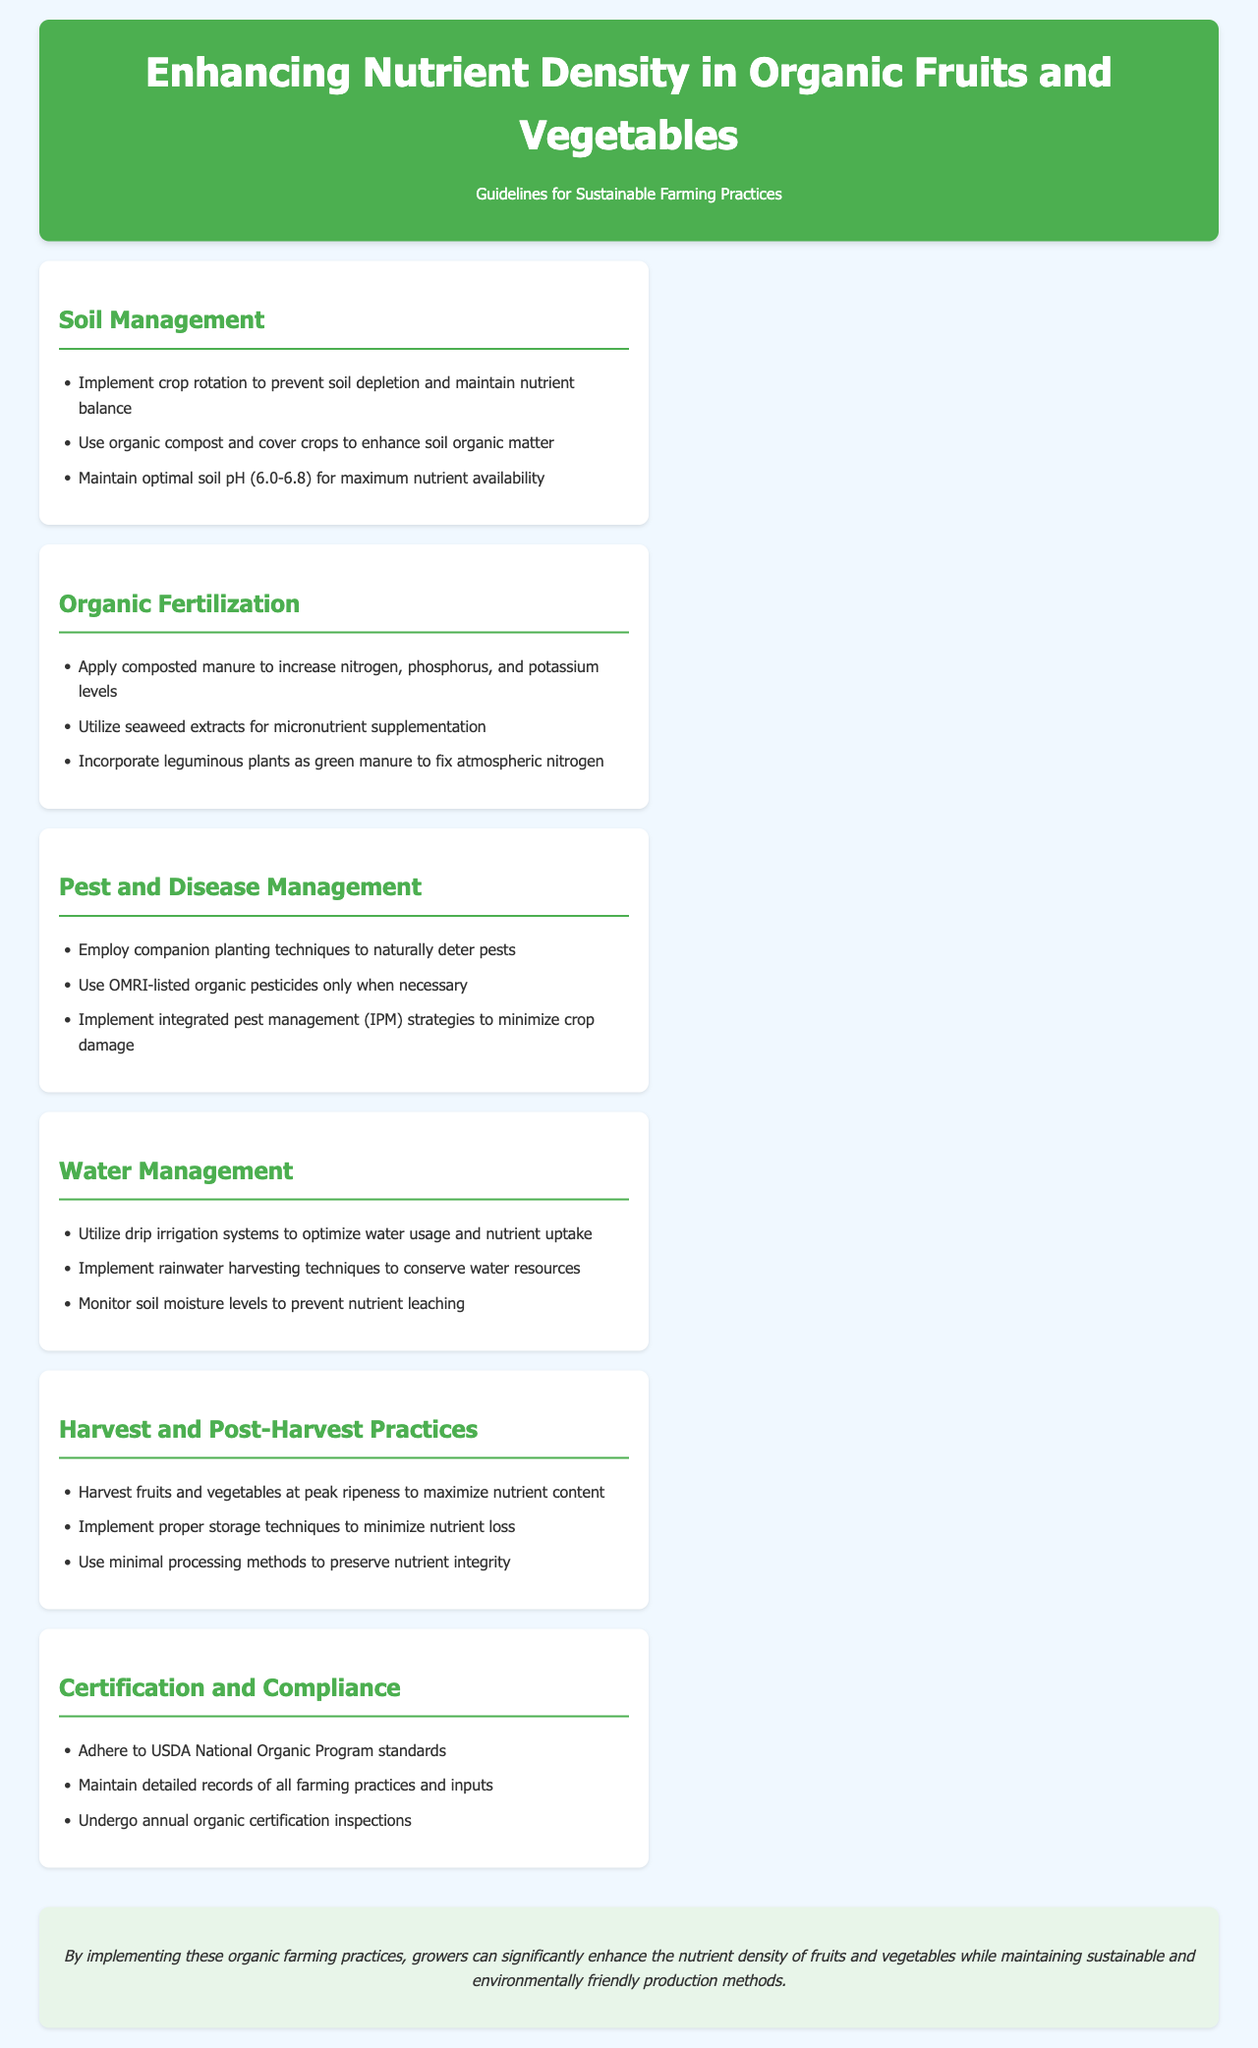What section discusses pest management strategies? The section that discusses pest management strategies is titled "Pest and Disease Management."
Answer: Pest and Disease Management What is the recommended optimal soil pH range? The document specifies that the optimal soil pH range is 6.0-6.8.
Answer: 6.0-6.8 Which organic practice is suggested to prevent soil depletion? The document mentions implementing crop rotation as a practice to prevent soil depletion.
Answer: Crop rotation How can growers conserve water resources according to the document? The document suggests implementing rainwater harvesting techniques to conserve water resources.
Answer: Rainwater harvesting What is the primary aim of applying composted manure in organic fertilization? The primary aim of applying composted manure is to increase nitrogen, phosphorus, and potassium levels.
Answer: Increase nitrogen, phosphorus, and potassium levels What farming compliance standards should be adhered to? Growers should adhere to USDA National Organic Program standards.
Answer: USDA National Organic Program standards Which technique is emphasized for optimizing water usage? The document emphasizes utilizing drip irrigation systems for optimizing water usage.
Answer: Drip irrigation systems What is the final takeaway from the document related to farming practices? The final takeaway is that by implementing these organic farming practices, growers can enhance the nutrient density of fruits and vegetables.
Answer: Enhance the nutrient density of fruits and vegetables 